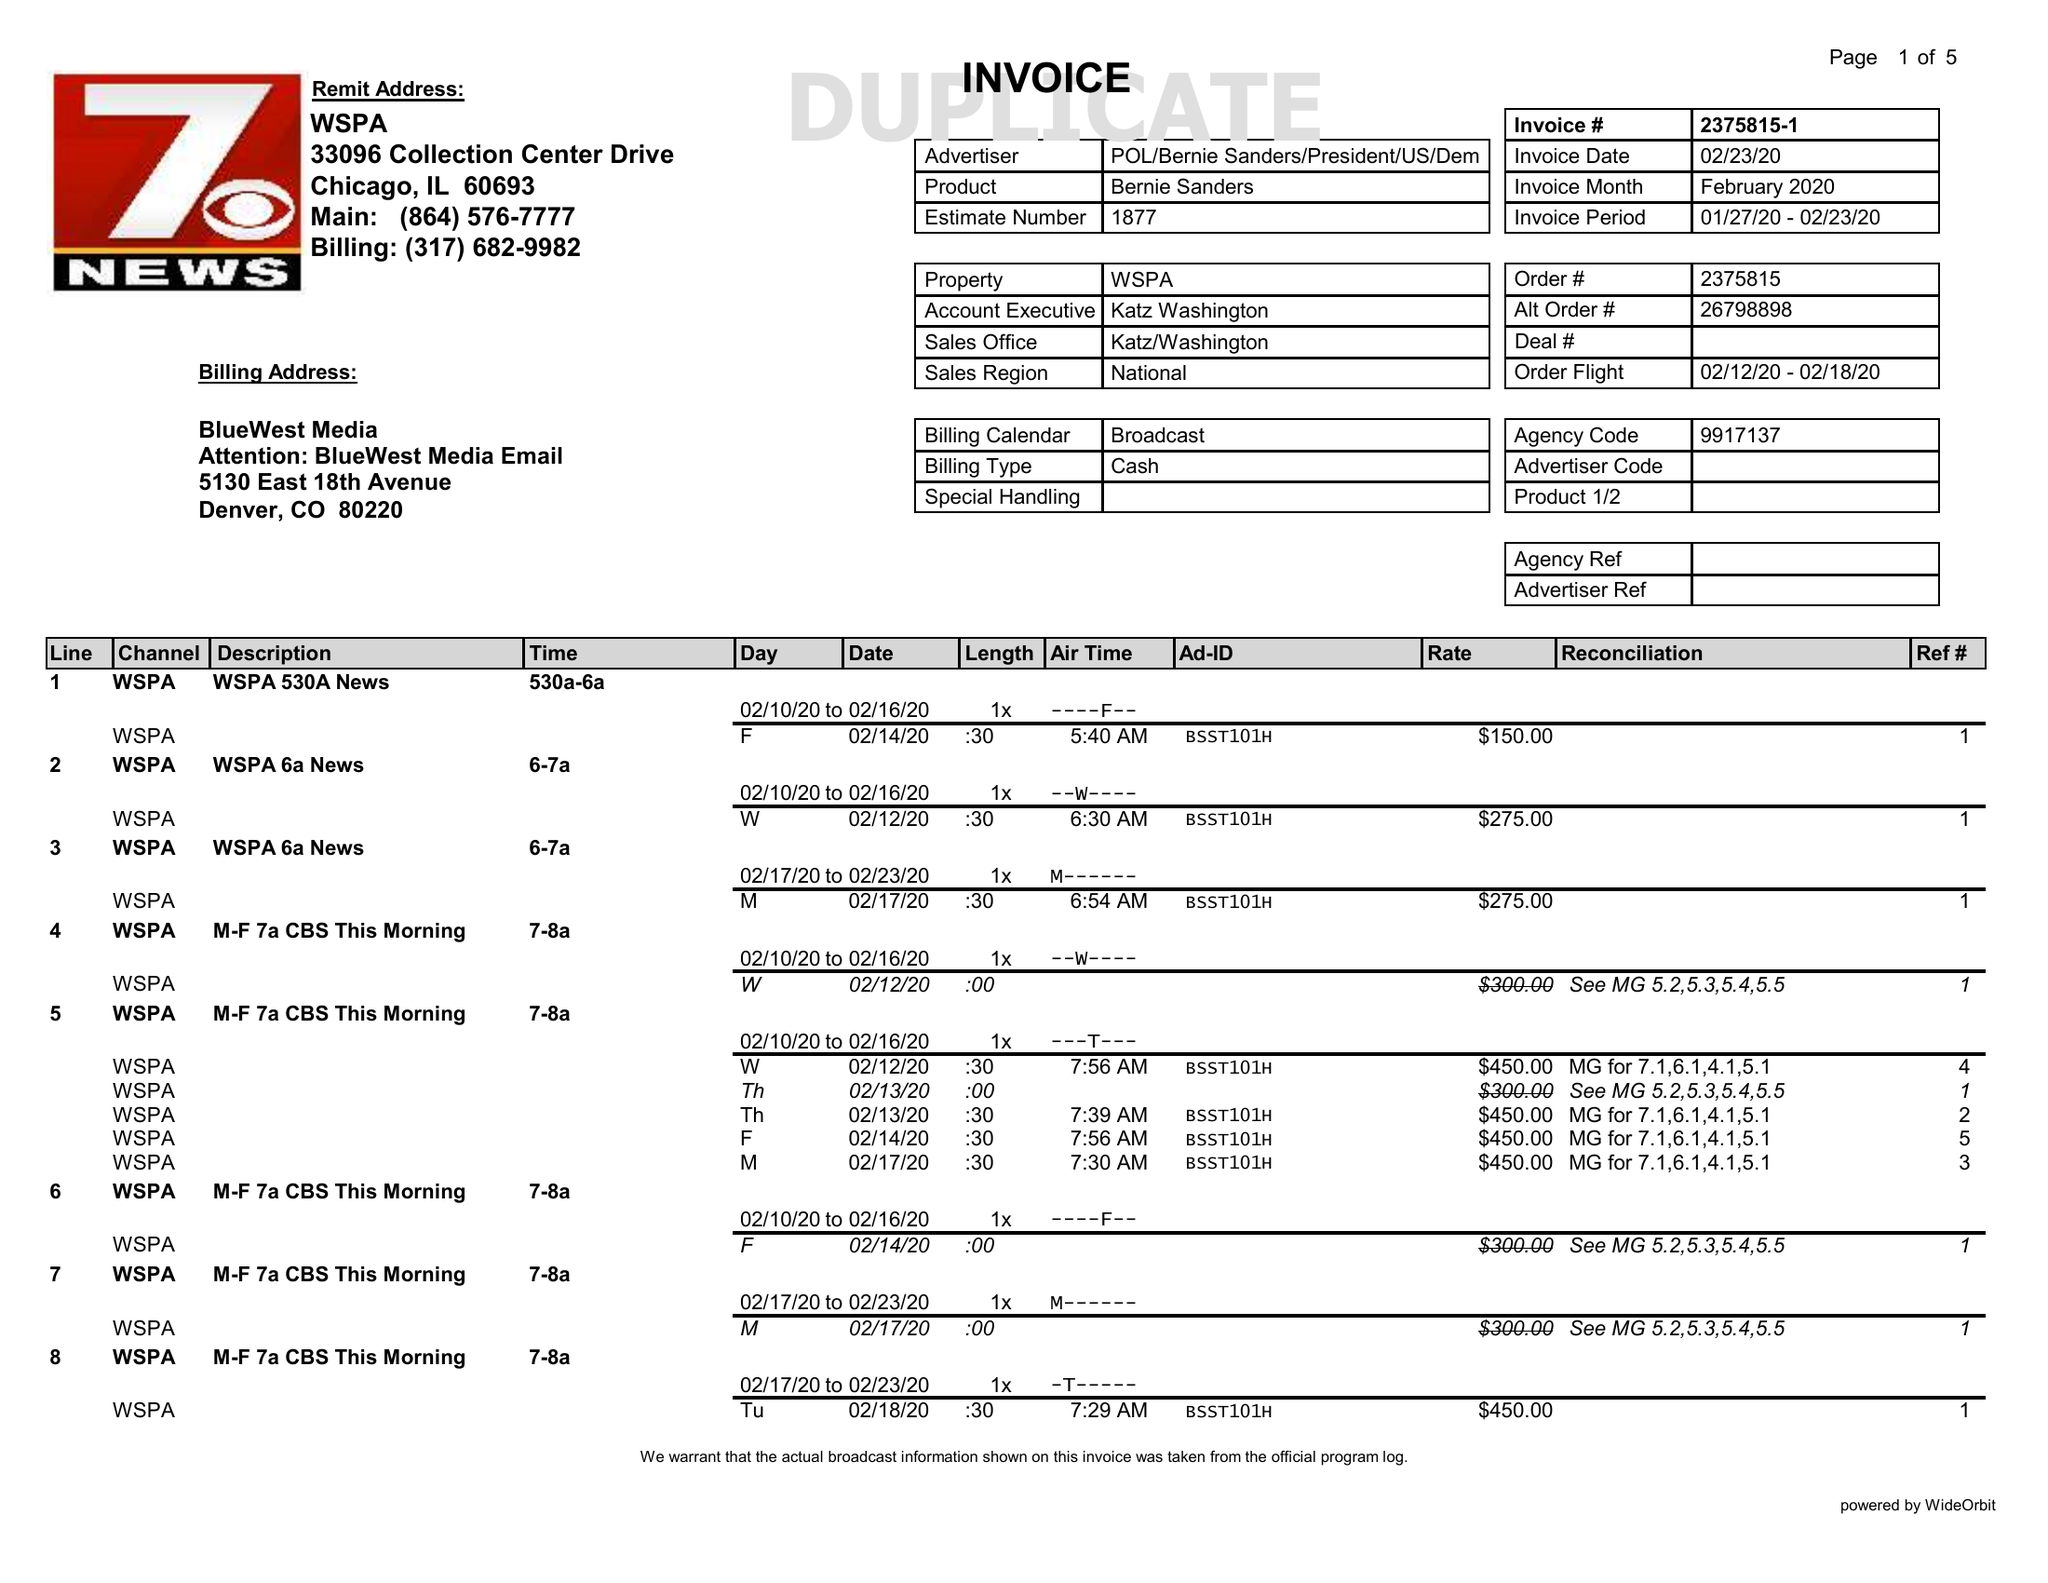What is the value for the flight_from?
Answer the question using a single word or phrase. 02/12/20 